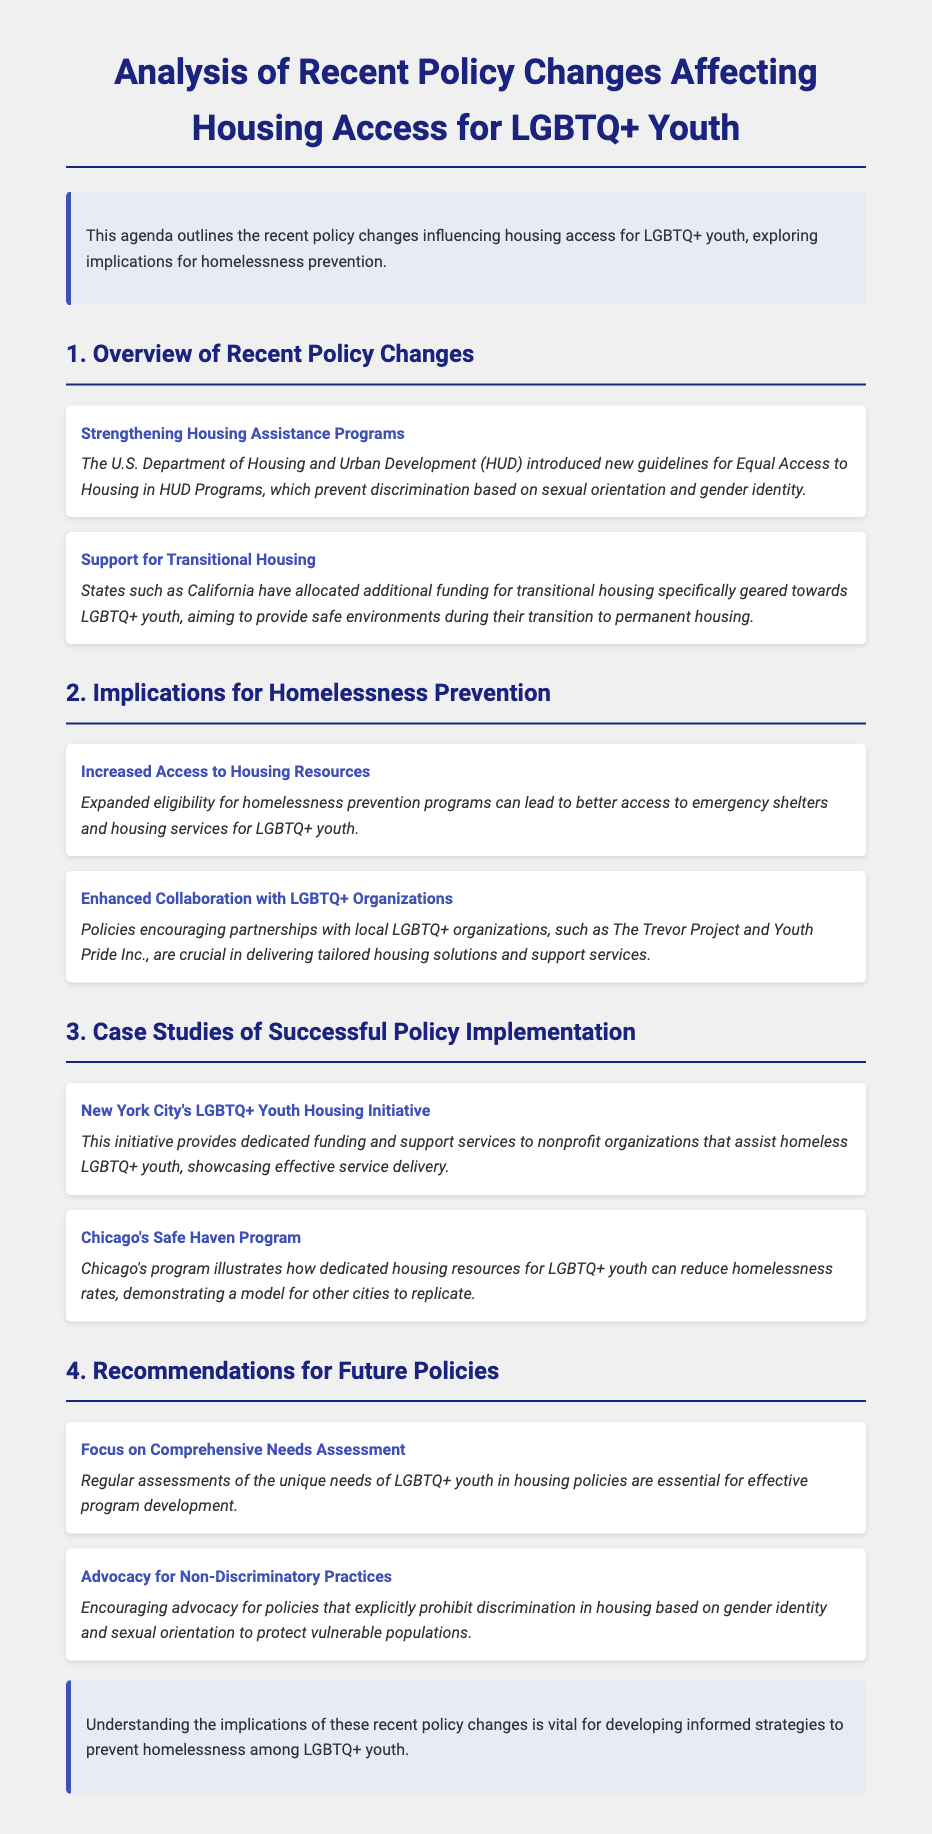What is the title of the document? The title of the document is clearly stated at the top of the rendered page.
Answer: Analysis of Recent Policy Changes Affecting Housing Access for LGBTQ+ Youth Who introduced the new guidelines for Equal Access to Housing? The document specifies that the U.S. Department of Housing and Urban Development (HUD) introduced the guidelines.
Answer: U.S. Department of Housing and Urban Development What state allocated additional funding for transitional housing for LGBTQ+ youth? The document mentions California in the context of funding for transitional housing.
Answer: California What is one implication of increased access to housing resources? The document outlines that expanded eligibility leads to better access to emergency shelters and housing services for LGBTQ+ youth.
Answer: Better access to emergency shelters Which city has an LGBTQ+ Youth Housing Initiative? The case studies section specifies New York City as having this initiative.
Answer: New York City What is a recommendation for future policies stated in the document? The document lists the importance of conducting regular assessments of the unique needs of LGBTQ+ youth.
Answer: Focus on Comprehensive Needs Assessment How does the Chicago’s Safe Haven Program contribute to homelessness rates? The document describes this program as demonstrating how dedicated housing resources can reduce homelessness rates.
Answer: Reduce homelessness rates What organization is partnered with policies for enhanced collaboration? The document specifically mentions The Trevor Project as an organization crucial for tailored housing solutions.
Answer: The Trevor Project What is the conclusion's main message? The conclusion emphasizes the importance of understanding policy implications for developing informed strategies.
Answer: Vital for developing informed strategies 